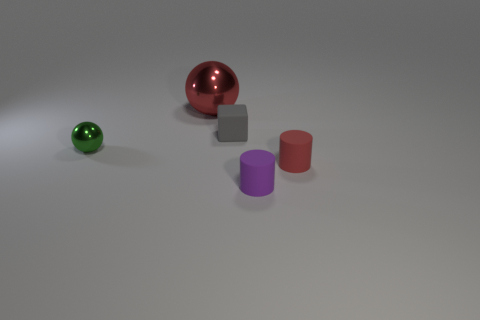Is there anything else that is the same size as the red ball?
Make the answer very short. No. Is there anything else that has the same material as the red cylinder?
Offer a very short reply. Yes. Are there any big things that have the same color as the block?
Offer a terse response. No. Is the number of large red metallic balls that are behind the large metallic ball greater than the number of large red spheres?
Offer a very short reply. No. Do the tiny green thing and the metallic object that is behind the small green metallic object have the same shape?
Give a very brief answer. Yes. Are any large green matte blocks visible?
Keep it short and to the point. No. What number of large things are either gray matte objects or green things?
Ensure brevity in your answer.  0. Is the number of tiny matte things that are on the right side of the tiny purple cylinder greater than the number of large things that are in front of the rubber block?
Give a very brief answer. Yes. Do the small green sphere and the red object in front of the large shiny object have the same material?
Provide a succinct answer. No. The block has what color?
Keep it short and to the point. Gray. 